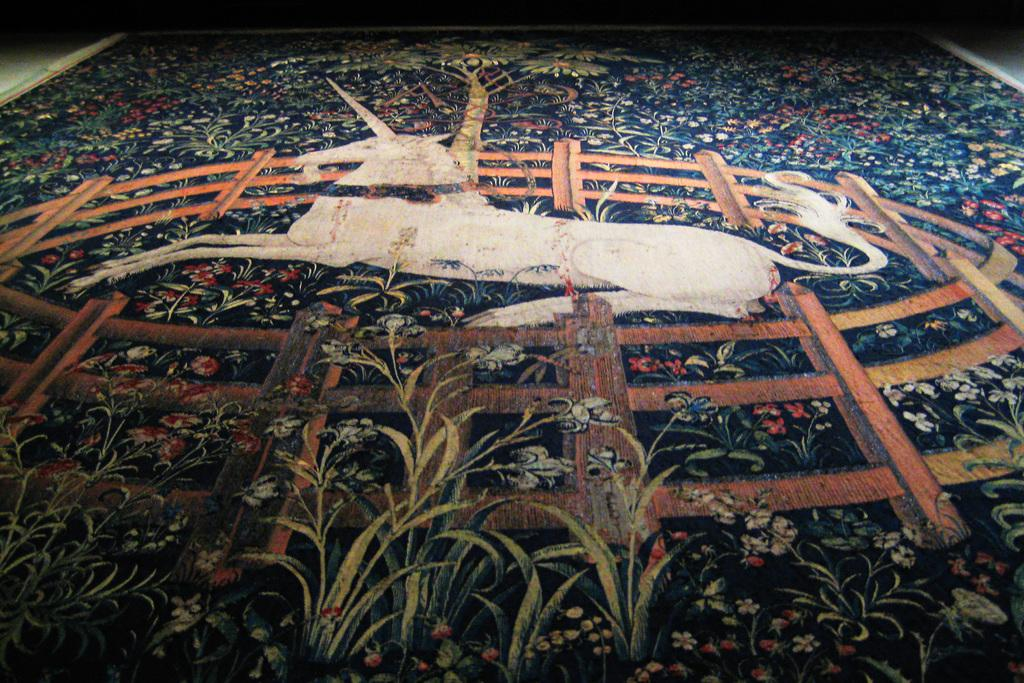What is on the floor in the image? There is a carpet on the floor in the image. What is depicted on the carpet? There are paintings of flowers and a unicorn on the carpet. What type of error can be seen in the painting of the unicorn's leg in the image? There is no painting of a unicorn's leg in the image, as the unicorn is depicted in its entirety, and no errors are visible. 